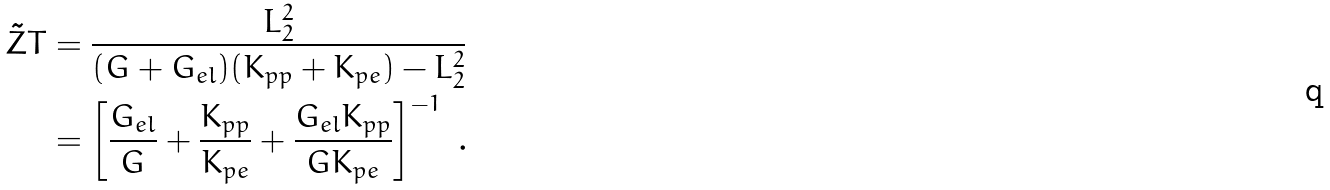<formula> <loc_0><loc_0><loc_500><loc_500>\tilde { Z } T & = \frac { L ^ { 2 } _ { 2 } } { ( G + G _ { e l } ) ( K _ { p p } + K _ { p e } ) - L ^ { 2 } _ { 2 } } \\ & = \left [ \frac { G _ { e l } } { G } + \frac { K _ { p p } } { K _ { p e } } + \frac { G _ { e l } K _ { p p } } { G K _ { p e } } \right ] ^ { - 1 } \ .</formula> 